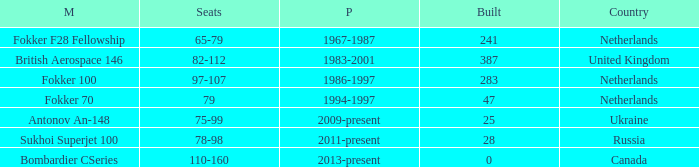Between which years were there 241 fokker 70 model cabins built? 1994-1997. 